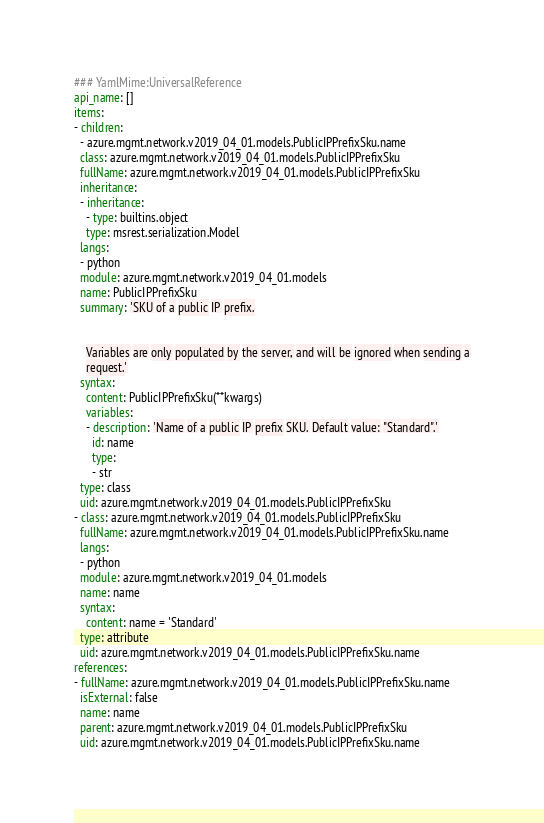Convert code to text. <code><loc_0><loc_0><loc_500><loc_500><_YAML_>### YamlMime:UniversalReference
api_name: []
items:
- children:
  - azure.mgmt.network.v2019_04_01.models.PublicIPPrefixSku.name
  class: azure.mgmt.network.v2019_04_01.models.PublicIPPrefixSku
  fullName: azure.mgmt.network.v2019_04_01.models.PublicIPPrefixSku
  inheritance:
  - inheritance:
    - type: builtins.object
    type: msrest.serialization.Model
  langs:
  - python
  module: azure.mgmt.network.v2019_04_01.models
  name: PublicIPPrefixSku
  summary: 'SKU of a public IP prefix.


    Variables are only populated by the server, and will be ignored when sending a
    request.'
  syntax:
    content: PublicIPPrefixSku(**kwargs)
    variables:
    - description: 'Name of a public IP prefix SKU. Default value: "Standard".'
      id: name
      type:
      - str
  type: class
  uid: azure.mgmt.network.v2019_04_01.models.PublicIPPrefixSku
- class: azure.mgmt.network.v2019_04_01.models.PublicIPPrefixSku
  fullName: azure.mgmt.network.v2019_04_01.models.PublicIPPrefixSku.name
  langs:
  - python
  module: azure.mgmt.network.v2019_04_01.models
  name: name
  syntax:
    content: name = 'Standard'
  type: attribute
  uid: azure.mgmt.network.v2019_04_01.models.PublicIPPrefixSku.name
references:
- fullName: azure.mgmt.network.v2019_04_01.models.PublicIPPrefixSku.name
  isExternal: false
  name: name
  parent: azure.mgmt.network.v2019_04_01.models.PublicIPPrefixSku
  uid: azure.mgmt.network.v2019_04_01.models.PublicIPPrefixSku.name
</code> 